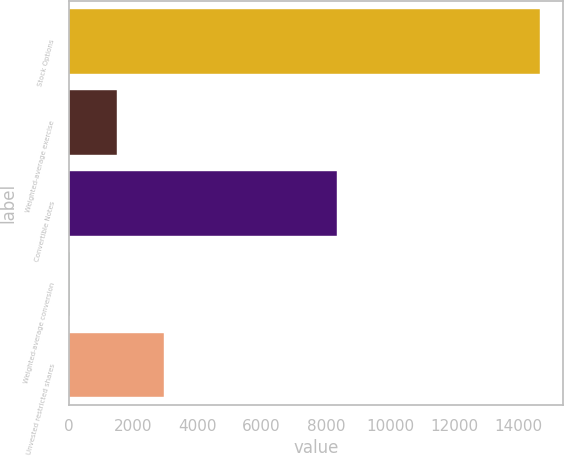Convert chart to OTSL. <chart><loc_0><loc_0><loc_500><loc_500><bar_chart><fcel>Stock Options<fcel>Weighted-average exercise<fcel>Convertible Notes<fcel>Weighted-average conversion<fcel>Unvested restricted shares<nl><fcel>14669<fcel>1484.14<fcel>8354<fcel>19.16<fcel>2949.12<nl></chart> 